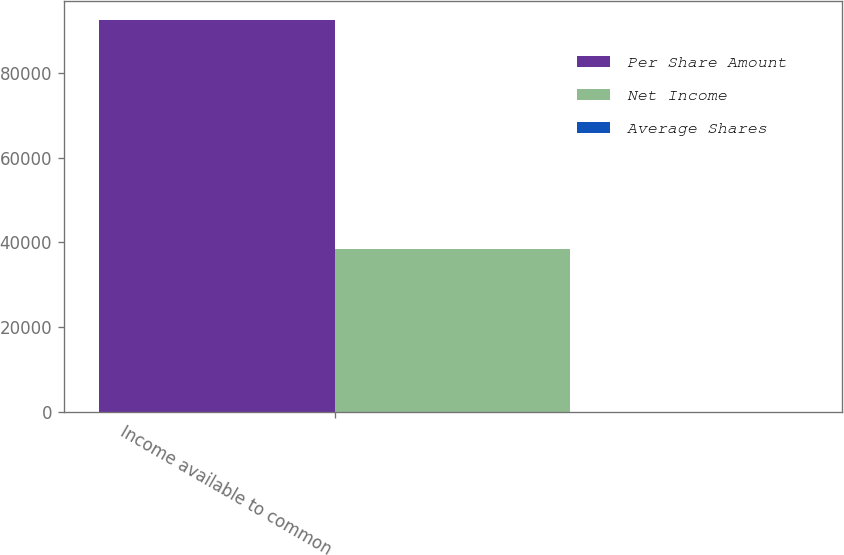Convert chart to OTSL. <chart><loc_0><loc_0><loc_500><loc_500><stacked_bar_chart><ecel><fcel>Income available to common<nl><fcel>Per Share Amount<fcel>92537<nl><fcel>Net Income<fcel>38489<nl><fcel>Average Shares<fcel>2.4<nl></chart> 